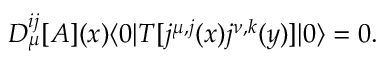<formula> <loc_0><loc_0><loc_500><loc_500>D _ { \mu } ^ { i j } [ A ] ( x ) \langle 0 | T [ j ^ { \mu , j } ( x ) j ^ { \nu , k } ( y ) ] | 0 \rangle = 0 .</formula> 